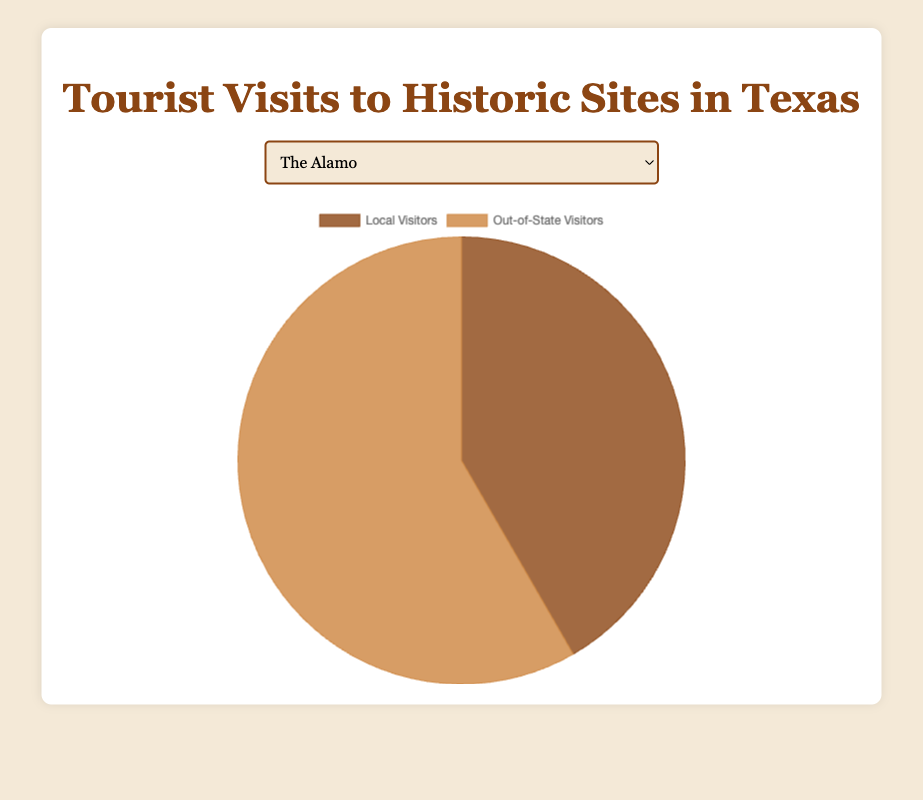Which site has a higher proportion of local visitors compared to out-of-state visitors? Compare the proportions of the local to out-of-state visitors for each site. For example, for "The Alamo," the local visitors (500,000) are less than out-of-state visitors (700,000). Repeat this comparison for each site. You’ll find that the "San Antonio Missions" has 200,000 local visitors to 300,000 out-of-state visitors; its 2:3 ratio shows a higher proportion of local visitors compared to sites like "Dealey Plaza" where local visitors account for 150,000 out of 250,000.
Answer: San Antonio Missions What is the total number of visitors to the Texas State Capitol? Sum up the number of local visitors and out-of-state visitors to find the total number of visitors for the Texas State Capitol: 400,000 + 500,000.
Answer: 900,000 Which site has the smallest number of local visitors? Look at the local visitor numbers for all sites. The site with the smallest number is the one with 150,000 local visitors, which is the Dealey Plaza National Historic Landmark District.
Answer: Dealey Plaza National Historic Landmark District How many more out-of-state visitors are there compared to local visitors at The Alamo? Subtract the number of local visitors from the number of out-of-state visitors for The Alamo: 700,000 - 500,000.
Answer: 200,000 Which site has the highest number of out-of-state visitors? Look at the out-of-state visitor numbers for all sites. The Alamo has the highest number with 700,000 visitors.
Answer: The Alamo What is the average number of visitors (local and out-of-state) for the Fort Worth Stockyards? Find the total number of visitors for the Fort Worth Stockyards: 350,000 local + 400,000 out-of-state = 750,000. Then divide by 2 to find the average: 750,000 / 2.
Answer: 375,000 Which has more visitors, San Antonio Missions or Dealey Plaza National Historic Landmark District? Sum the local and out-of-state visitors for each site: San Antonio Missions (200,000 + 300,000 = 500,000) and Dealey Plaza (150,000 + 250,000 = 400,000), then compare the totals.
Answer: San Antonio Missions What is the combined number of local visitors across all five historic sites? Sum the local visitor numbers for all sites: 500,000 (The Alamo) + 200,000 (San Antonio Missions) + 150,000 (Dealey Plaza National Historic Landmark District) + 400,000 (Texas State Capitol) + 350,000 (Fort Worth Stockyards).
Answer: 1,600,000 